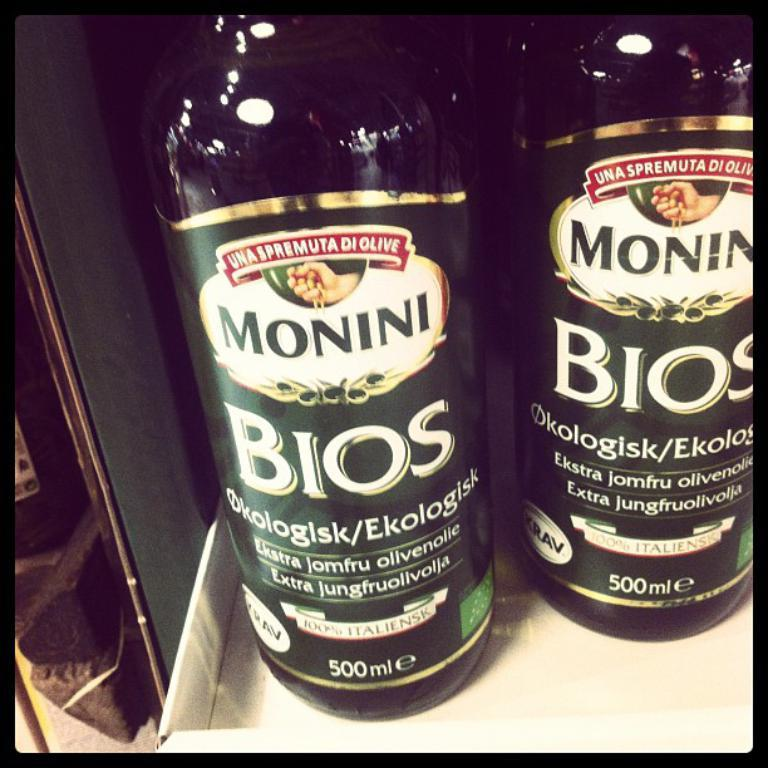<image>
Write a terse but informative summary of the picture. Two bottles of Monini Bios sit next to each other 